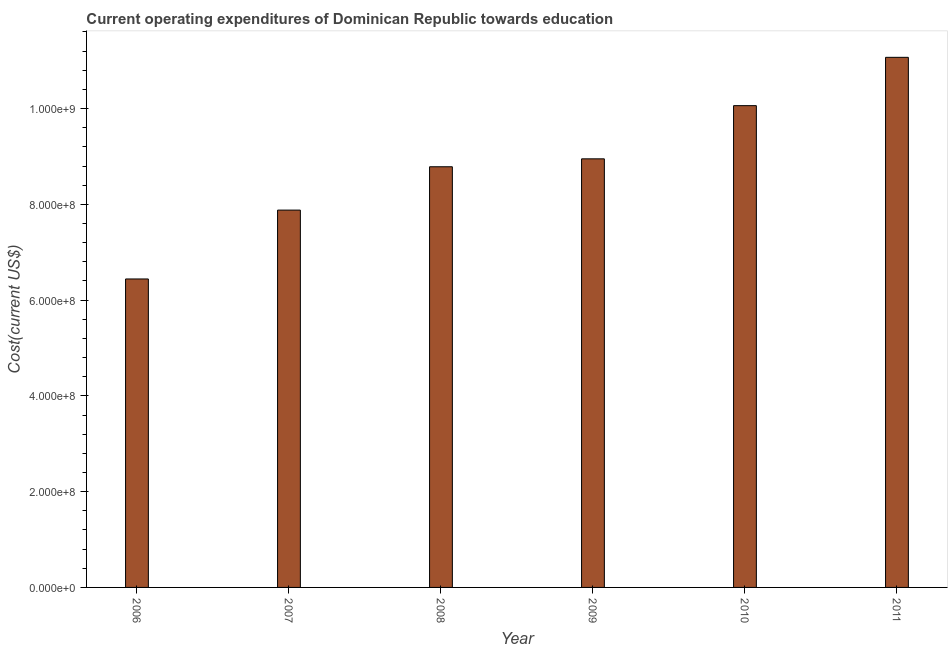Does the graph contain grids?
Your response must be concise. No. What is the title of the graph?
Your answer should be compact. Current operating expenditures of Dominican Republic towards education. What is the label or title of the X-axis?
Keep it short and to the point. Year. What is the label or title of the Y-axis?
Keep it short and to the point. Cost(current US$). What is the education expenditure in 2006?
Your answer should be compact. 6.44e+08. Across all years, what is the maximum education expenditure?
Your answer should be very brief. 1.11e+09. Across all years, what is the minimum education expenditure?
Provide a short and direct response. 6.44e+08. In which year was the education expenditure maximum?
Make the answer very short. 2011. What is the sum of the education expenditure?
Give a very brief answer. 5.32e+09. What is the difference between the education expenditure in 2008 and 2011?
Offer a terse response. -2.29e+08. What is the average education expenditure per year?
Ensure brevity in your answer.  8.86e+08. What is the median education expenditure?
Offer a terse response. 8.87e+08. In how many years, is the education expenditure greater than 600000000 US$?
Your answer should be very brief. 6. What is the ratio of the education expenditure in 2007 to that in 2010?
Make the answer very short. 0.78. Is the education expenditure in 2008 less than that in 2009?
Provide a short and direct response. Yes. Is the difference between the education expenditure in 2009 and 2011 greater than the difference between any two years?
Provide a succinct answer. No. What is the difference between the highest and the second highest education expenditure?
Offer a very short reply. 1.01e+08. Is the sum of the education expenditure in 2007 and 2010 greater than the maximum education expenditure across all years?
Ensure brevity in your answer.  Yes. What is the difference between the highest and the lowest education expenditure?
Make the answer very short. 4.63e+08. In how many years, is the education expenditure greater than the average education expenditure taken over all years?
Provide a short and direct response. 3. How many bars are there?
Offer a terse response. 6. What is the difference between two consecutive major ticks on the Y-axis?
Provide a succinct answer. 2.00e+08. Are the values on the major ticks of Y-axis written in scientific E-notation?
Your answer should be very brief. Yes. What is the Cost(current US$) in 2006?
Give a very brief answer. 6.44e+08. What is the Cost(current US$) in 2007?
Offer a very short reply. 7.88e+08. What is the Cost(current US$) in 2008?
Provide a short and direct response. 8.78e+08. What is the Cost(current US$) in 2009?
Your answer should be very brief. 8.95e+08. What is the Cost(current US$) of 2010?
Make the answer very short. 1.01e+09. What is the Cost(current US$) in 2011?
Offer a terse response. 1.11e+09. What is the difference between the Cost(current US$) in 2006 and 2007?
Offer a terse response. -1.44e+08. What is the difference between the Cost(current US$) in 2006 and 2008?
Ensure brevity in your answer.  -2.34e+08. What is the difference between the Cost(current US$) in 2006 and 2009?
Offer a very short reply. -2.51e+08. What is the difference between the Cost(current US$) in 2006 and 2010?
Provide a succinct answer. -3.62e+08. What is the difference between the Cost(current US$) in 2006 and 2011?
Offer a very short reply. -4.63e+08. What is the difference between the Cost(current US$) in 2007 and 2008?
Offer a terse response. -9.05e+07. What is the difference between the Cost(current US$) in 2007 and 2009?
Provide a succinct answer. -1.07e+08. What is the difference between the Cost(current US$) in 2007 and 2010?
Offer a very short reply. -2.18e+08. What is the difference between the Cost(current US$) in 2007 and 2011?
Offer a terse response. -3.19e+08. What is the difference between the Cost(current US$) in 2008 and 2009?
Offer a very short reply. -1.65e+07. What is the difference between the Cost(current US$) in 2008 and 2010?
Offer a terse response. -1.28e+08. What is the difference between the Cost(current US$) in 2008 and 2011?
Provide a short and direct response. -2.29e+08. What is the difference between the Cost(current US$) in 2009 and 2010?
Keep it short and to the point. -1.11e+08. What is the difference between the Cost(current US$) in 2009 and 2011?
Give a very brief answer. -2.12e+08. What is the difference between the Cost(current US$) in 2010 and 2011?
Give a very brief answer. -1.01e+08. What is the ratio of the Cost(current US$) in 2006 to that in 2007?
Ensure brevity in your answer.  0.82. What is the ratio of the Cost(current US$) in 2006 to that in 2008?
Offer a very short reply. 0.73. What is the ratio of the Cost(current US$) in 2006 to that in 2009?
Your answer should be very brief. 0.72. What is the ratio of the Cost(current US$) in 2006 to that in 2010?
Offer a very short reply. 0.64. What is the ratio of the Cost(current US$) in 2006 to that in 2011?
Offer a very short reply. 0.58. What is the ratio of the Cost(current US$) in 2007 to that in 2008?
Ensure brevity in your answer.  0.9. What is the ratio of the Cost(current US$) in 2007 to that in 2010?
Your response must be concise. 0.78. What is the ratio of the Cost(current US$) in 2007 to that in 2011?
Provide a succinct answer. 0.71. What is the ratio of the Cost(current US$) in 2008 to that in 2009?
Your answer should be very brief. 0.98. What is the ratio of the Cost(current US$) in 2008 to that in 2010?
Your answer should be very brief. 0.87. What is the ratio of the Cost(current US$) in 2008 to that in 2011?
Your answer should be compact. 0.79. What is the ratio of the Cost(current US$) in 2009 to that in 2010?
Provide a succinct answer. 0.89. What is the ratio of the Cost(current US$) in 2009 to that in 2011?
Offer a terse response. 0.81. What is the ratio of the Cost(current US$) in 2010 to that in 2011?
Your answer should be very brief. 0.91. 